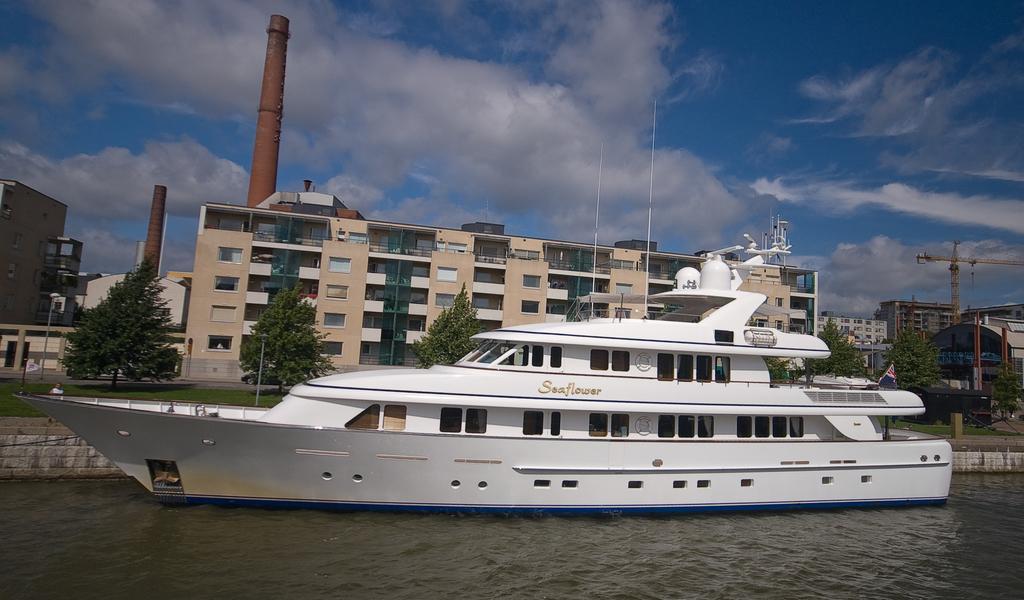How would you summarize this image in a sentence or two? In this image there is a ship in the water. In the background there is a factory. In front of the factory there are trees. At the top there is sky. 